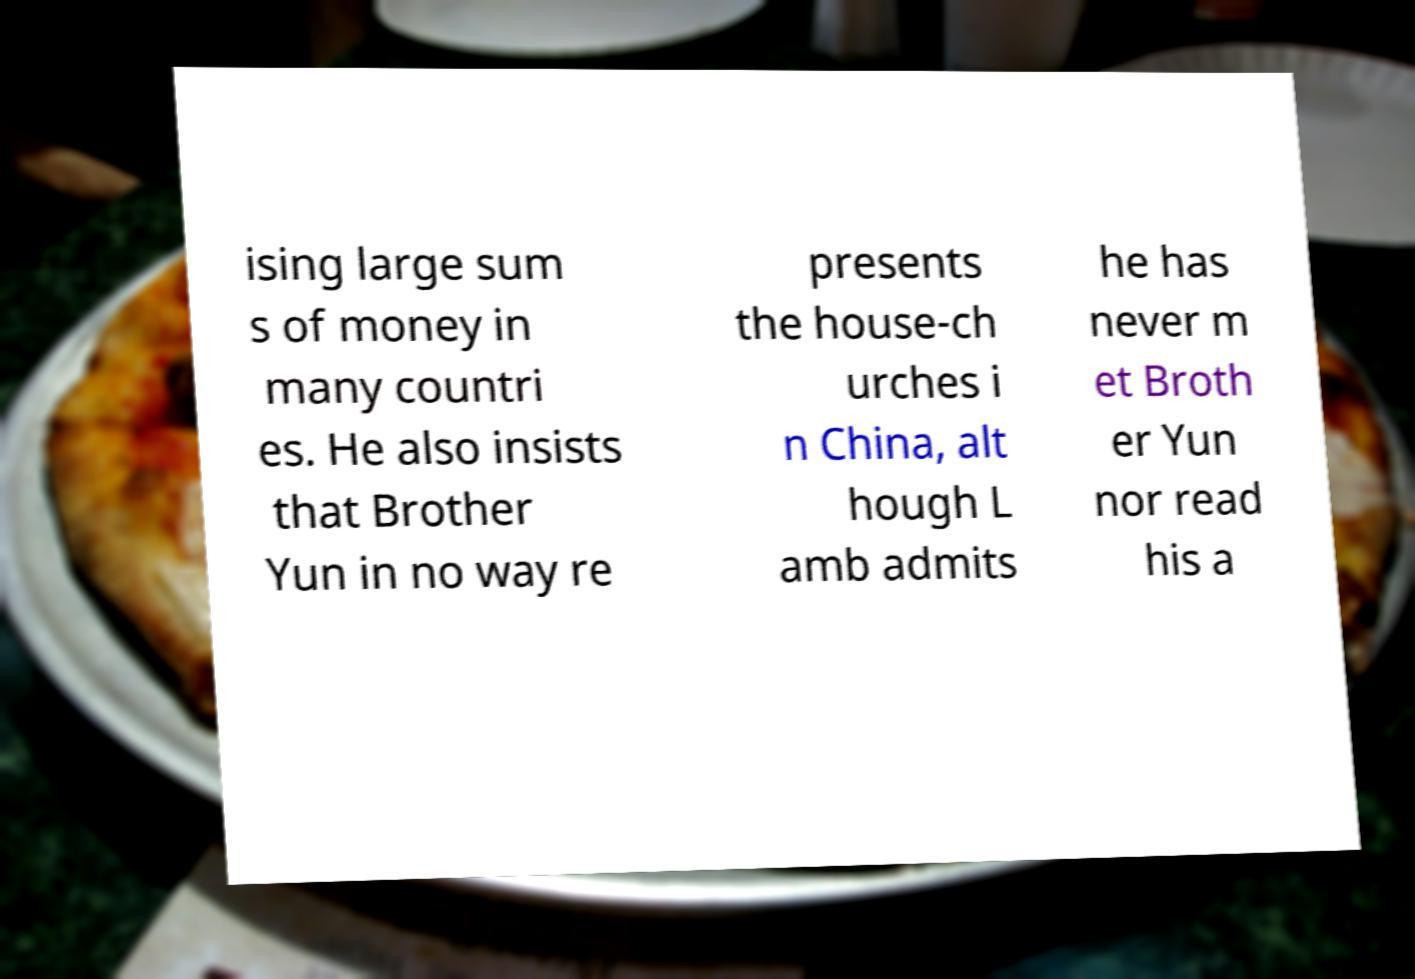Please read and relay the text visible in this image. What does it say? ising large sum s of money in many countri es. He also insists that Brother Yun in no way re presents the house-ch urches i n China, alt hough L amb admits he has never m et Broth er Yun nor read his a 